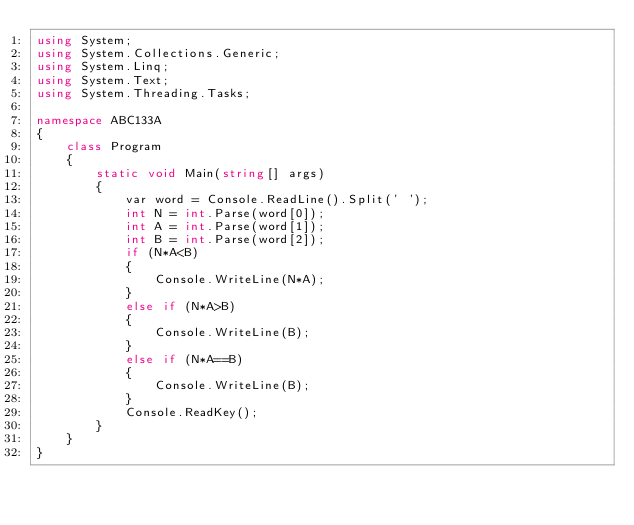Convert code to text. <code><loc_0><loc_0><loc_500><loc_500><_C#_>using System;
using System.Collections.Generic;
using System.Linq;
using System.Text;
using System.Threading.Tasks;

namespace ABC133A
{
    class Program
    {
        static void Main(string[] args)
        {
            var word = Console.ReadLine().Split(' ');
            int N = int.Parse(word[0]);
            int A = int.Parse(word[1]);
            int B = int.Parse(word[2]);
            if (N*A<B)
            {
                Console.WriteLine(N*A);
            }
            else if (N*A>B)
            {
                Console.WriteLine(B);
            }
            else if (N*A==B)
            {
                Console.WriteLine(B);
            }
            Console.ReadKey();
        }
    }
}</code> 